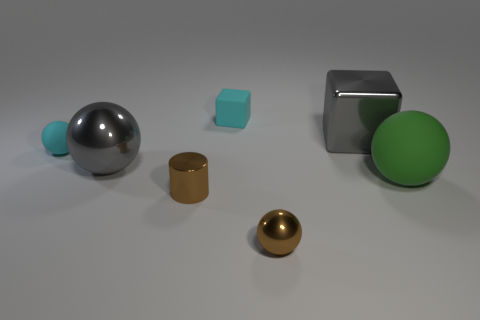Subtract all tiny shiny spheres. How many spheres are left? 3 Add 2 large shiny cubes. How many objects exist? 9 Subtract all gray cubes. How many cubes are left? 1 Subtract all cylinders. How many objects are left? 6 Subtract 1 blocks. How many blocks are left? 1 Subtract all blue balls. How many gray blocks are left? 1 Add 3 brown things. How many brown things are left? 5 Add 6 large gray metallic cylinders. How many large gray metallic cylinders exist? 6 Subtract 1 cyan cubes. How many objects are left? 6 Subtract all blue spheres. Subtract all gray cylinders. How many spheres are left? 4 